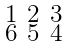<formula> <loc_0><loc_0><loc_500><loc_500>\begin{smallmatrix} 1 & 2 & 3 \\ 6 & 5 & 4 \end{smallmatrix}</formula> 